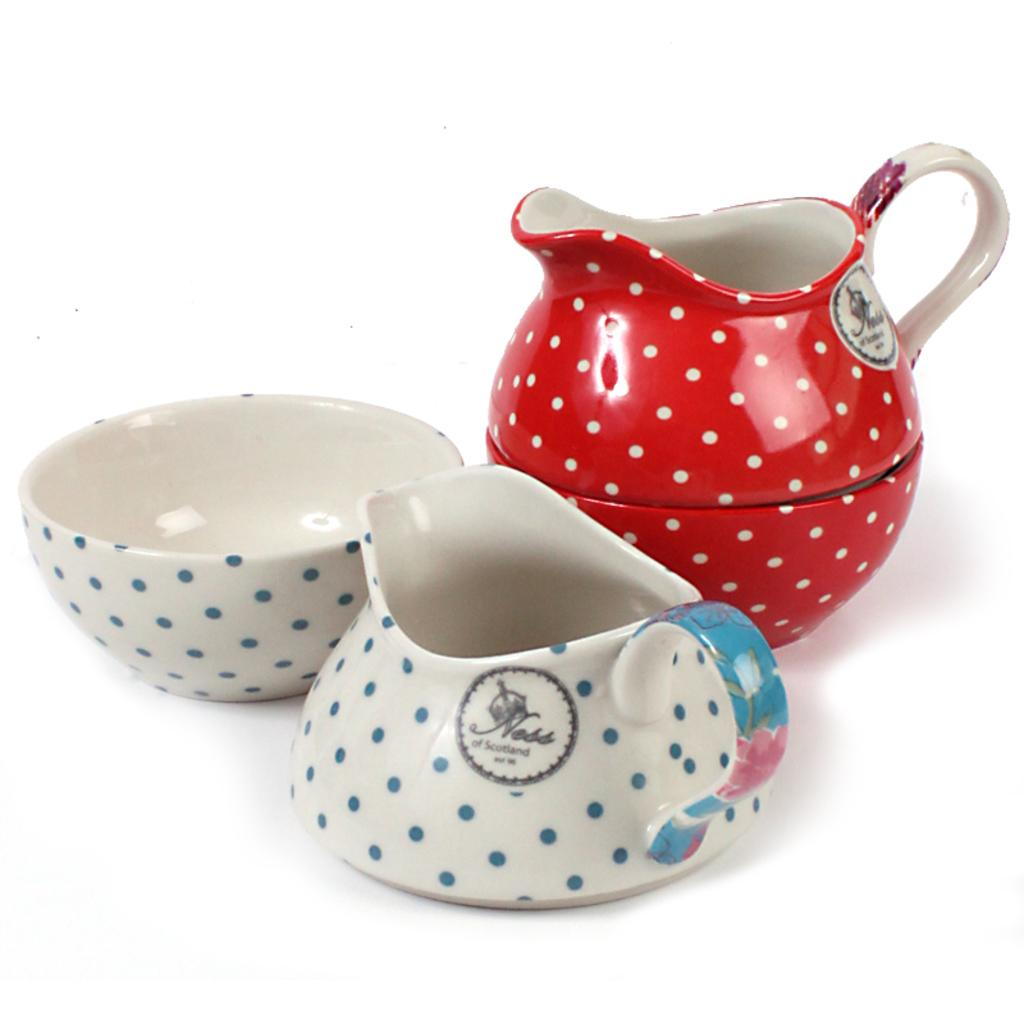What type of containers are present in the image? There are jars in the image. What else can be seen in the image besides the jars? There is a bowl in the image. What is written or printed on the jars? There is text on the jars. What color is the background of the image? The background of the image is white. Can you tell me what type of joke is written on the jars in the image? There is no joke written on the jars in the image; there is only text, which could be a label or description. 